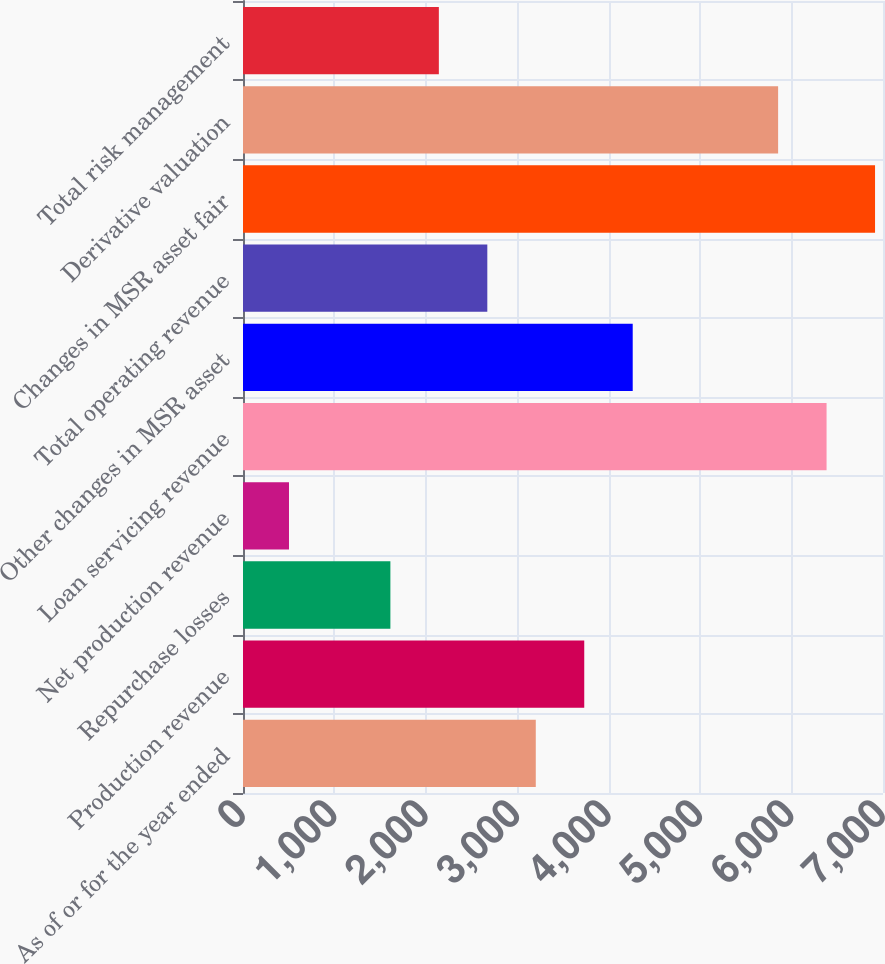Convert chart. <chart><loc_0><loc_0><loc_500><loc_500><bar_chart><fcel>As of or for the year ended<fcel>Production revenue<fcel>Repurchase losses<fcel>Net production revenue<fcel>Loan servicing revenue<fcel>Other changes in MSR asset<fcel>Total operating revenue<fcel>Changes in MSR asset fair<fcel>Derivative valuation<fcel>Total risk management<nl><fcel>3202.3<fcel>3732.4<fcel>1612<fcel>503<fcel>6382.9<fcel>4262.5<fcel>2672.2<fcel>6913<fcel>5852.8<fcel>2142.1<nl></chart> 